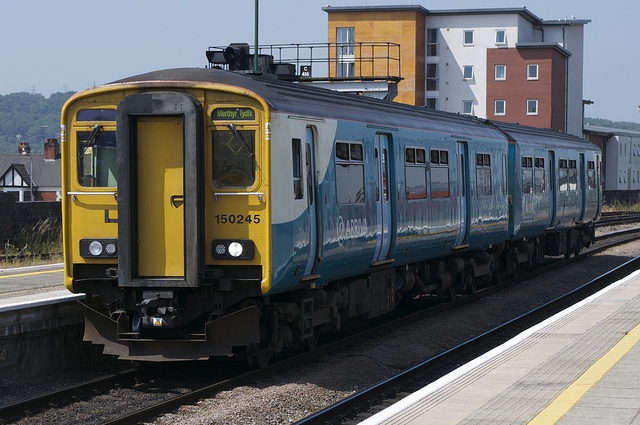Describe the objects in this image and their specific colors. I can see a train in lightblue, black, gray, olive, and blue tones in this image. 